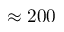Convert formula to latex. <formula><loc_0><loc_0><loc_500><loc_500>\approx 2 0 0</formula> 